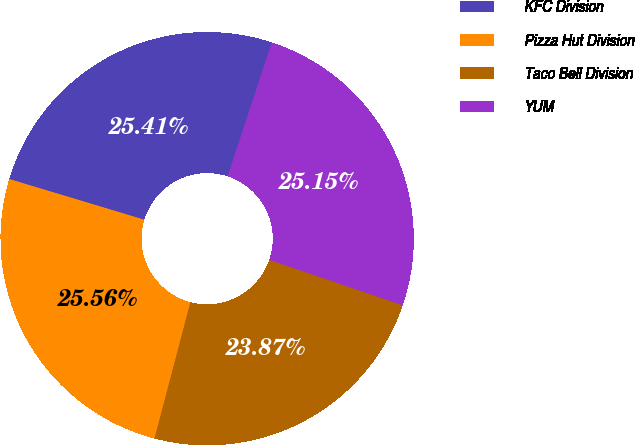Convert chart to OTSL. <chart><loc_0><loc_0><loc_500><loc_500><pie_chart><fcel>KFC Division<fcel>Pizza Hut Division<fcel>Taco Bell Division<fcel>YUM<nl><fcel>25.41%<fcel>25.56%<fcel>23.87%<fcel>25.15%<nl></chart> 